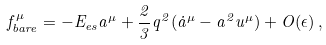<formula> <loc_0><loc_0><loc_500><loc_500>f _ { b a r e } ^ { \mu } = - E _ { e s } a ^ { \mu } + \frac { 2 } { 3 } q ^ { 2 } ( \dot { a } ^ { \mu } - a ^ { 2 } u ^ { \mu } ) + O ( \epsilon ) \, ,</formula> 